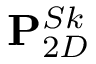Convert formula to latex. <formula><loc_0><loc_0><loc_500><loc_500>P _ { 2 D } ^ { S k }</formula> 